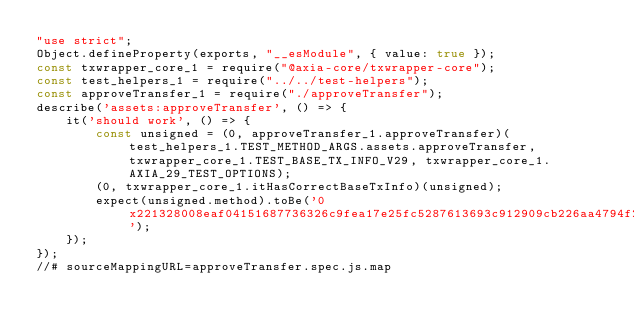Convert code to text. <code><loc_0><loc_0><loc_500><loc_500><_JavaScript_>"use strict";
Object.defineProperty(exports, "__esModule", { value: true });
const txwrapper_core_1 = require("@axia-core/txwrapper-core");
const test_helpers_1 = require("../../test-helpers");
const approveTransfer_1 = require("./approveTransfer");
describe('assets:approveTransfer', () => {
    it('should work', () => {
        const unsigned = (0, approveTransfer_1.approveTransfer)(test_helpers_1.TEST_METHOD_ARGS.assets.approveTransfer, txwrapper_core_1.TEST_BASE_TX_INFO_V29, txwrapper_core_1.AXIA_29_TEST_OPTIONS);
        (0, txwrapper_core_1.itHasCorrectBaseTxInfo)(unsigned);
        expect(unsigned.method).toBe('0x221328008eaf04151687736326c9fea17e25fc5287613693c912909cb226aa4794f26a484913');
    });
});
//# sourceMappingURL=approveTransfer.spec.js.map</code> 